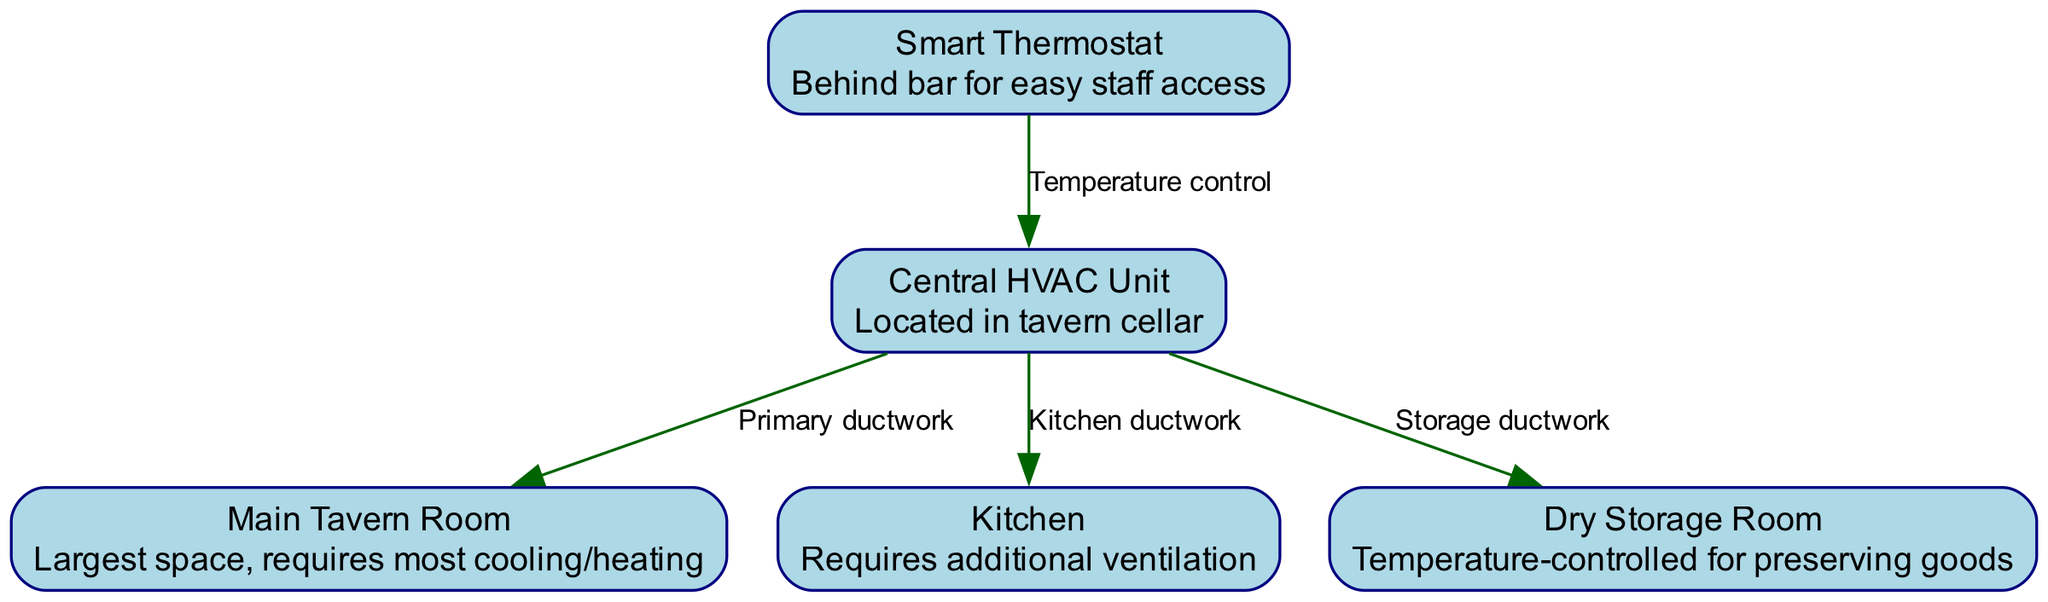What is the central component of the HVAC system? The node labeled as "Central HVAC Unit" is indicated as the primary component in the diagram, clearly identified in the nodes section.
Answer: Central HVAC Unit How many nodes are present in the diagram? By counting the distinct entries in the "nodes" section, there are five different nodes listed, each representing different parts of the HVAC system.
Answer: 5 What is the purpose of the Smart Thermostat? The description of the "Smart Thermostat" node notes it is for "Temperature control," meaning its function is to control the temperature throughout the tavern.
Answer: Temperature control Which room requires additional ventilation? The node labeled "Kitchen" explicitly states it "Requires additional ventilation," highlighting its need for better air management compared to other spaces.
Answer: Kitchen How many ductwork connections does the Central HVAC Unit have? Counting the edges leading from the "Central HVAC Unit," there are three distinct connections (to Main Tavern Room, Kitchen, and Storage), indicating it services three areas.
Answer: 3 What connects the Smart Thermostat to the Central HVAC Unit? The relationship labeled as "Temperature control" connecting the "Smart Thermostat" and "Central HVAC Unit" demonstrates that the thermostat is responsible for regulating the HVAC functions based on temperature settings.
Answer: Temperature control What is the largest space requiring HVAC adjustments in the tavern? The "Main Tavern Room" is labeled as "Largest space" in the description, indicating it has the highest demand for heating and cooling compared to other areas.
Answer: Main Tavern Room Which room is specifically temperature-controlled to preserve goods? The "Dry Storage Room" node mentions it is "Temperature-controlled for preserving goods," indicating its specific function within the tavern's HVAC system.
Answer: Dry Storage Room What indicates the primary airflow direction in the HVAC diagram? The edges from the "Central HVAC Unit" to the other nodes represent the primary airflow directions, with arrows denoting the flow from the unit to each specific space like the kitchen and storage.
Answer: Primary ductwork 